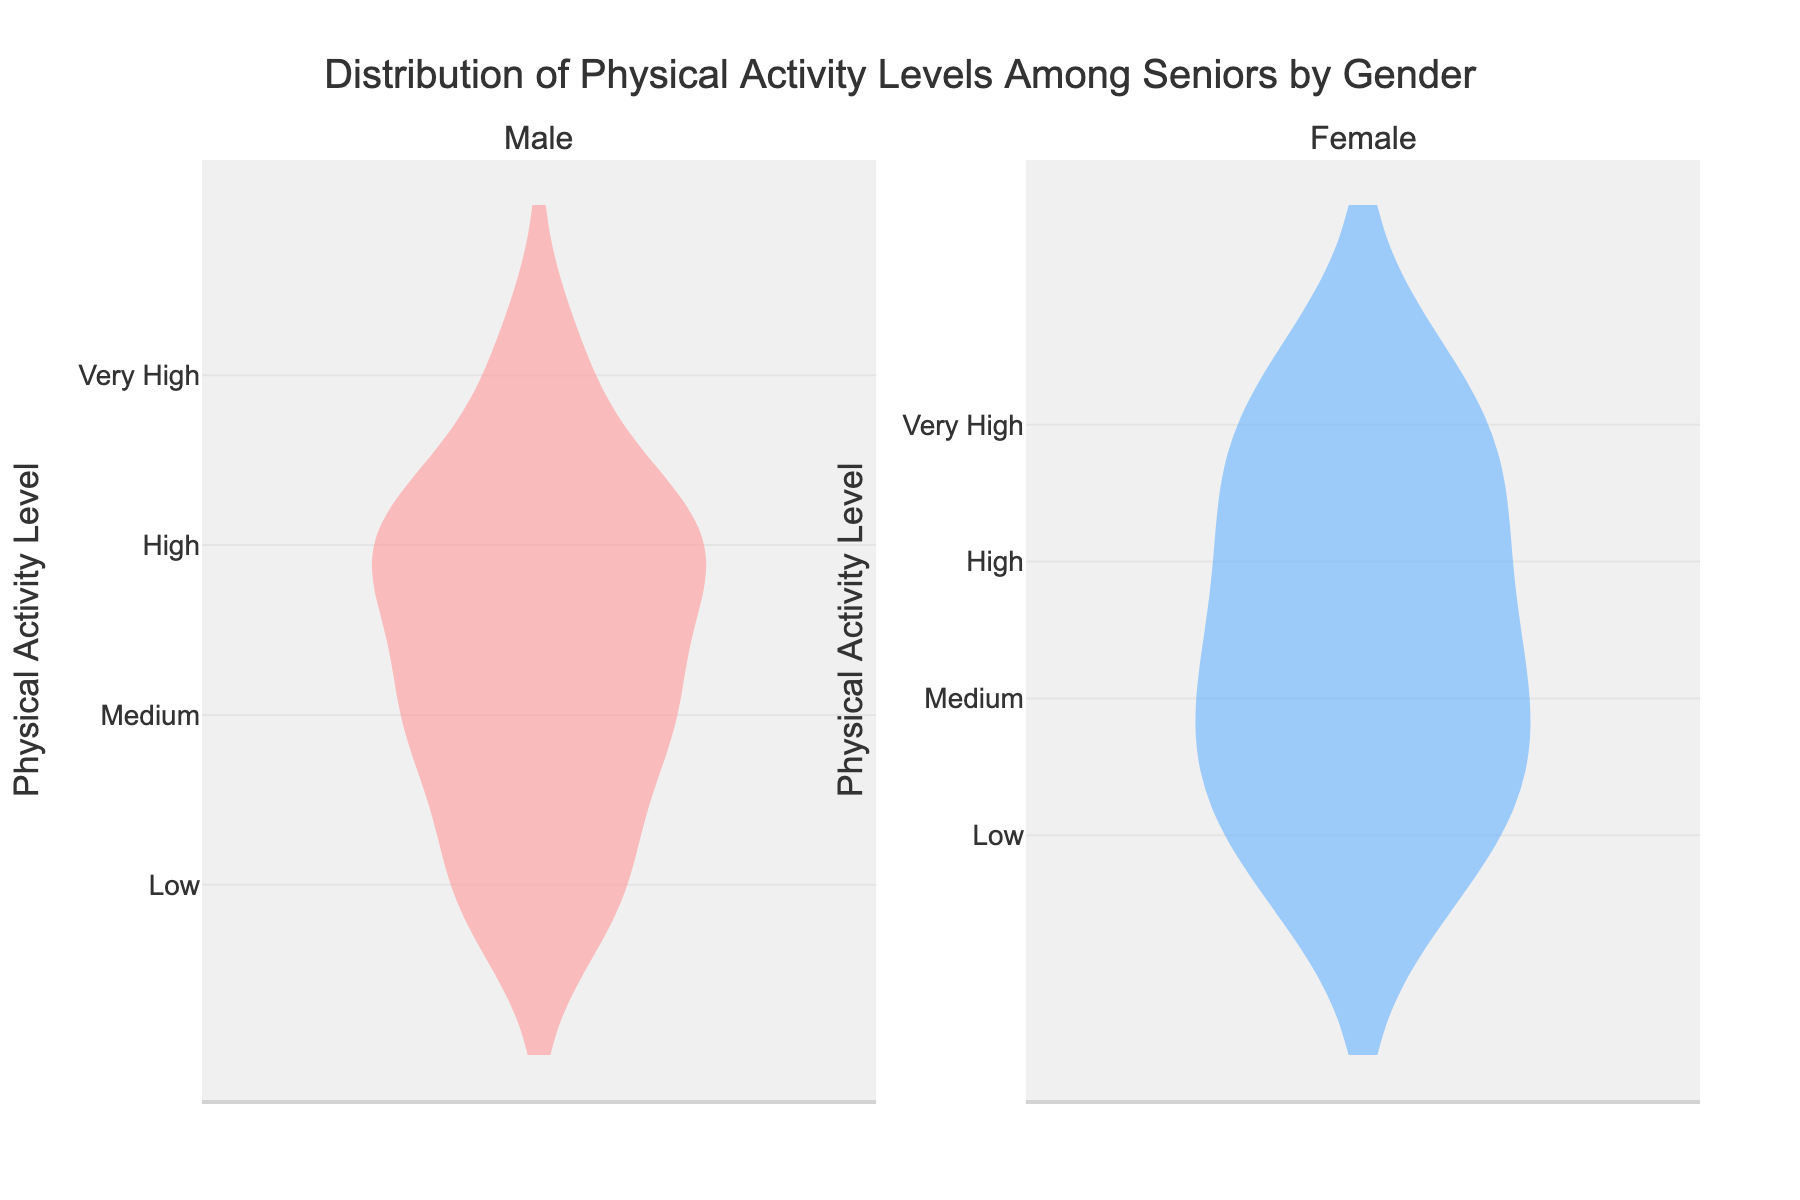Which gender has a higher median physical activity level? To answer this, look at the horizontal line inside the violin plot for each gender. The horizontal line indicates the median level. Compare the median lines between the two plots.
Answer: Female What are the physical activity levels displayed on the y-axis? Refer to the labels along the y-axis of the plot to identify the physical activity levels.
Answer: Low, Medium, High, Very High Which subplot shows more variability in physical activity levels? Look at the width and spread of the violin plots for both genders. The wider and more spread out the plot is, the more variability it shows.
Answer: Female How many physical activity levels are considered for both genders? Count the distinct levels specified on the y-axis of the plot.
Answer: Four What is the title of the figure? The title of the figure is typically displayed at the top of the plot.
Answer: Distribution of Physical Activity Levels Among Seniors by Gender Which gender shows a larger proportion of seniors with a Very High physical activity level? Compare the width of the violin plots at the "Very High" level for both genders. The wider portion suggests a larger proportion.
Answer: Female Is the average physical activity level higher for males or females? Observe the position of the mean line (usually a dashed line) inside each violin plot. Compare the average positions between the two plots.
Answer: Female Between males and females, which gender shows the highest level of physical activity more frequently? Identify the frequency by looking at the wider sections of the violin plots at the highest level of physical activity.
Answer: Female What colors are used in the violin plots for each gender? Notice the fill colors of the violin plots for the two genders.
Answer: Male: Blue, Female: Pink 